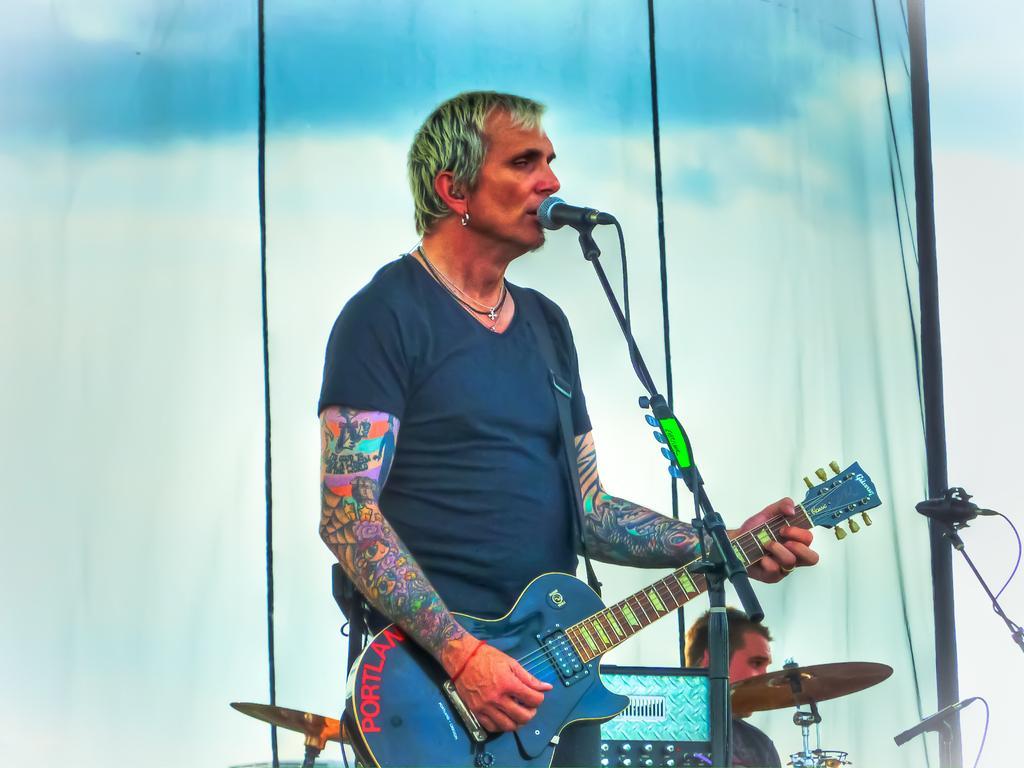Please provide a concise description of this image. In this picture we can see a man standing in front of a mike , singing and playing guitar. Aside to this person we can see a man near to the drums. These are cymbals. On the background we can see a blue and white colour cloth. We can see tattoos on man's hand. 